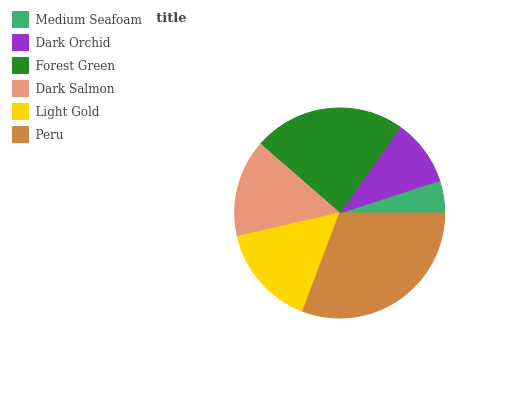Is Medium Seafoam the minimum?
Answer yes or no. Yes. Is Peru the maximum?
Answer yes or no. Yes. Is Dark Orchid the minimum?
Answer yes or no. No. Is Dark Orchid the maximum?
Answer yes or no. No. Is Dark Orchid greater than Medium Seafoam?
Answer yes or no. Yes. Is Medium Seafoam less than Dark Orchid?
Answer yes or no. Yes. Is Medium Seafoam greater than Dark Orchid?
Answer yes or no. No. Is Dark Orchid less than Medium Seafoam?
Answer yes or no. No. Is Light Gold the high median?
Answer yes or no. Yes. Is Dark Salmon the low median?
Answer yes or no. Yes. Is Peru the high median?
Answer yes or no. No. Is Dark Orchid the low median?
Answer yes or no. No. 